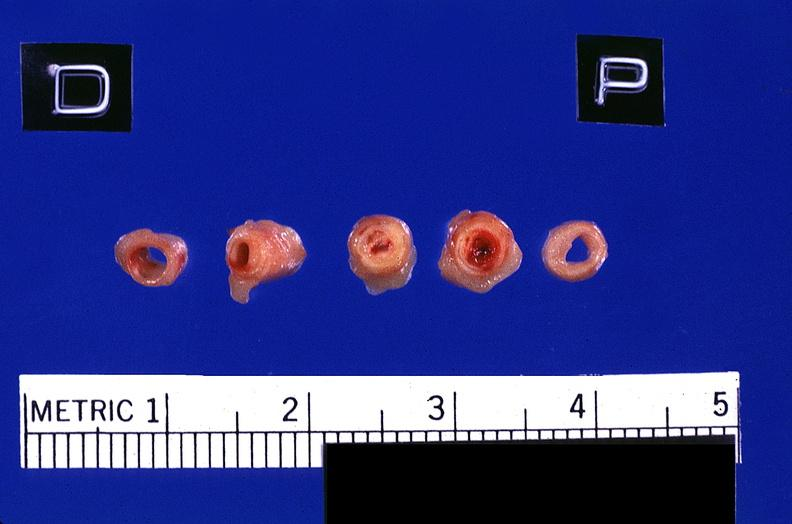what does this image show?
Answer the question using a single word or phrase. Coronary artery with atherosclerosis and thrombotic occlusion 